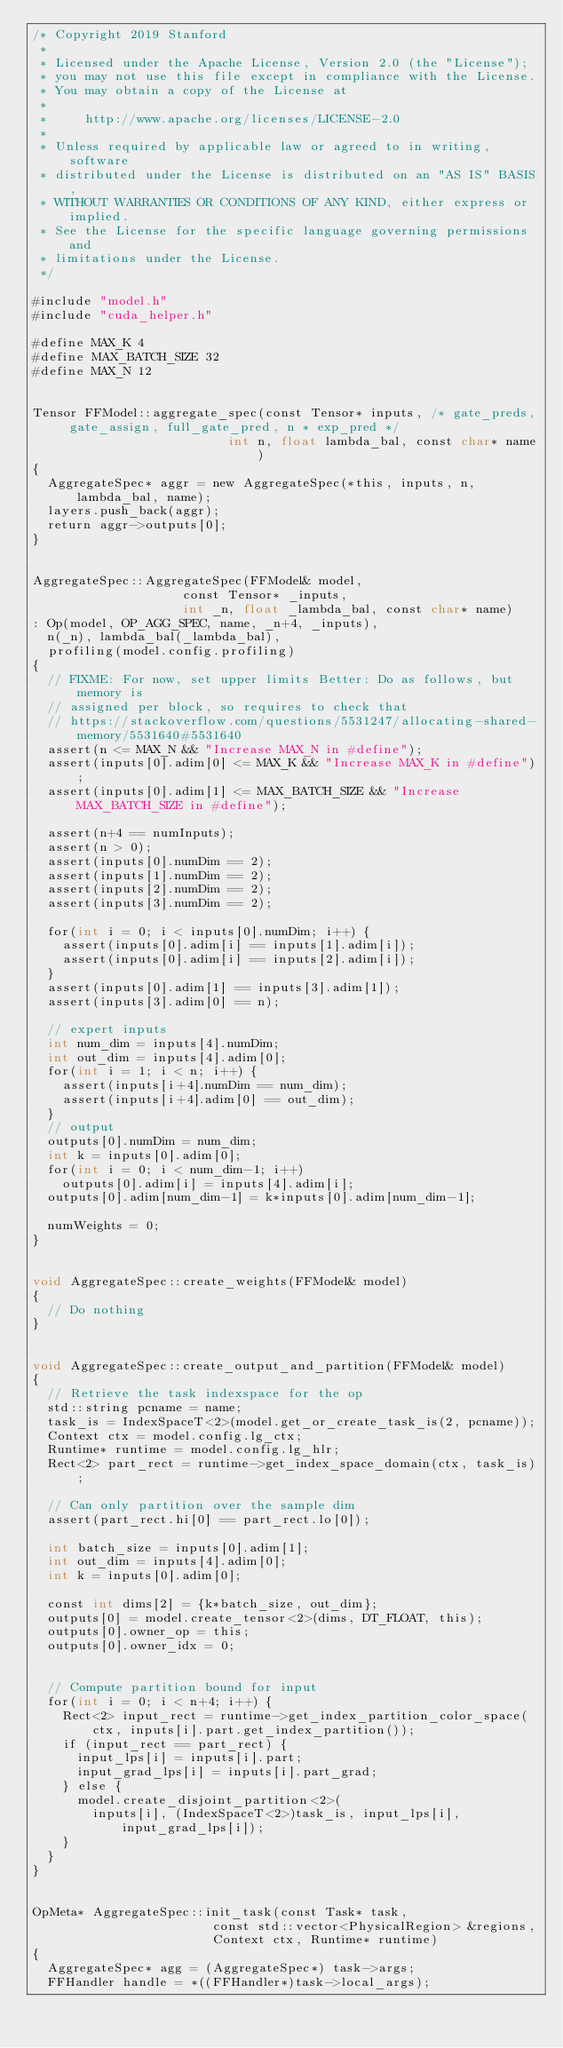Convert code to text. <code><loc_0><loc_0><loc_500><loc_500><_Cuda_>/* Copyright 2019 Stanford
 *
 * Licensed under the Apache License, Version 2.0 (the "License");
 * you may not use this file except in compliance with the License.
 * You may obtain a copy of the License at
 *
 *     http://www.apache.org/licenses/LICENSE-2.0
 *
 * Unless required by applicable law or agreed to in writing, software
 * distributed under the License is distributed on an "AS IS" BASIS,
 * WITHOUT WARRANTIES OR CONDITIONS OF ANY KIND, either express or implied.
 * See the License for the specific language governing permissions and
 * limitations under the License.
 */

#include "model.h"
#include "cuda_helper.h"

#define MAX_K 4
#define MAX_BATCH_SIZE 32
#define MAX_N 12


Tensor FFModel::aggregate_spec(const Tensor* inputs, /* gate_preds, gate_assign, full_gate_pred, n * exp_pred */
                          int n, float lambda_bal, const char* name)
{
  AggregateSpec* aggr = new AggregateSpec(*this, inputs, n, lambda_bal, name);
  layers.push_back(aggr);
  return aggr->outputs[0];
}


AggregateSpec::AggregateSpec(FFModel& model,
                    const Tensor* _inputs,
                    int _n, float _lambda_bal, const char* name)
: Op(model, OP_AGG_SPEC, name, _n+4, _inputs),
  n(_n), lambda_bal(_lambda_bal),
  profiling(model.config.profiling)
{
  // FIXME: For now, set upper limits Better: Do as follows, but memory is
  // assigned per block, so requires to check that
  // https://stackoverflow.com/questions/5531247/allocating-shared-memory/5531640#5531640
  assert(n <= MAX_N && "Increase MAX_N in #define");
  assert(inputs[0].adim[0] <= MAX_K && "Increase MAX_K in #define");
  assert(inputs[0].adim[1] <= MAX_BATCH_SIZE && "Increase MAX_BATCH_SIZE in #define");

  assert(n+4 == numInputs);
  assert(n > 0);
  assert(inputs[0].numDim == 2);
  assert(inputs[1].numDim == 2);
  assert(inputs[2].numDim == 2);
  assert(inputs[3].numDim == 2);

  for(int i = 0; i < inputs[0].numDim; i++) {
    assert(inputs[0].adim[i] == inputs[1].adim[i]);
    assert(inputs[0].adim[i] == inputs[2].adim[i]);
  }
  assert(inputs[0].adim[1] == inputs[3].adim[1]);
  assert(inputs[3].adim[0] == n);

  // expert inputs
  int num_dim = inputs[4].numDim;
  int out_dim = inputs[4].adim[0];
  for(int i = 1; i < n; i++) {
    assert(inputs[i+4].numDim == num_dim);
    assert(inputs[i+4].adim[0] == out_dim);
  }
  // output
  outputs[0].numDim = num_dim;
  int k = inputs[0].adim[0];
  for(int i = 0; i < num_dim-1; i++)
    outputs[0].adim[i] = inputs[4].adim[i];
  outputs[0].adim[num_dim-1] = k*inputs[0].adim[num_dim-1];

  numWeights = 0;
}


void AggregateSpec::create_weights(FFModel& model)
{
  // Do nothing
}


void AggregateSpec::create_output_and_partition(FFModel& model)
{
  // Retrieve the task indexspace for the op
  std::string pcname = name;
  task_is = IndexSpaceT<2>(model.get_or_create_task_is(2, pcname));
  Context ctx = model.config.lg_ctx;
  Runtime* runtime = model.config.lg_hlr;
  Rect<2> part_rect = runtime->get_index_space_domain(ctx, task_is);

  // Can only partition over the sample dim
  assert(part_rect.hi[0] == part_rect.lo[0]);

  int batch_size = inputs[0].adim[1];
  int out_dim = inputs[4].adim[0];
  int k = inputs[0].adim[0];

  const int dims[2] = {k*batch_size, out_dim};
  outputs[0] = model.create_tensor<2>(dims, DT_FLOAT, this);
  outputs[0].owner_op = this;
  outputs[0].owner_idx = 0;


  // Compute partition bound for input
  for(int i = 0; i < n+4; i++) {
    Rect<2> input_rect = runtime->get_index_partition_color_space(
        ctx, inputs[i].part.get_index_partition());
    if (input_rect == part_rect) {
      input_lps[i] = inputs[i].part;
      input_grad_lps[i] = inputs[i].part_grad;
    } else {
      model.create_disjoint_partition<2>(
        inputs[i], (IndexSpaceT<2>)task_is, input_lps[i], input_grad_lps[i]);
    }
  }
}


OpMeta* AggregateSpec::init_task(const Task* task,
                        const std::vector<PhysicalRegion> &regions,
                        Context ctx, Runtime* runtime)
{
  AggregateSpec* agg = (AggregateSpec*) task->args;
  FFHandler handle = *((FFHandler*)task->local_args);</code> 